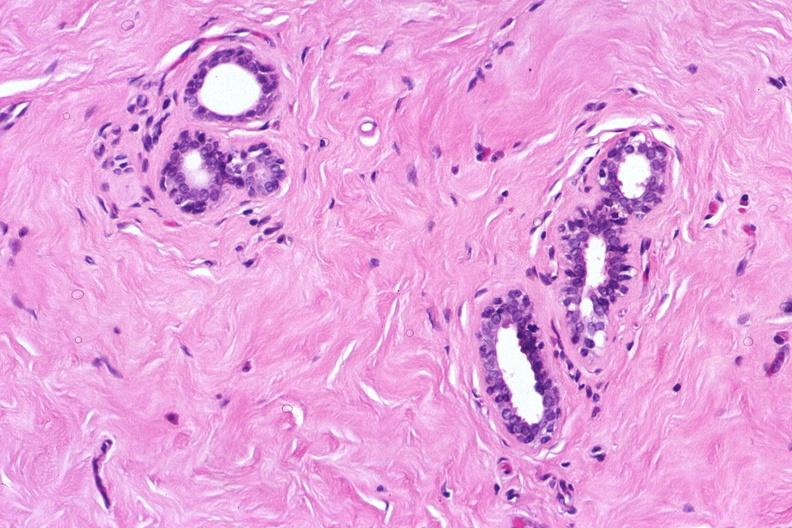s gangrene toe in infant present?
Answer the question using a single word or phrase. No 